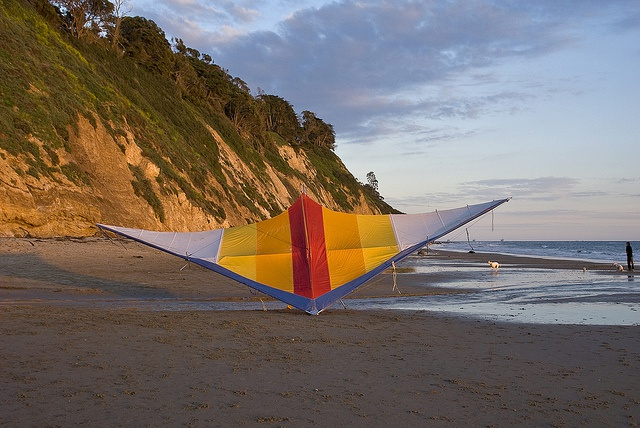Describe the objects in this image and their specific colors. I can see kite in olive, orange, darkgray, and brown tones, people in olive, black, maroon, gray, and purple tones, dog in olive, tan, and black tones, and dog in olive, gray, black, and maroon tones in this image. 